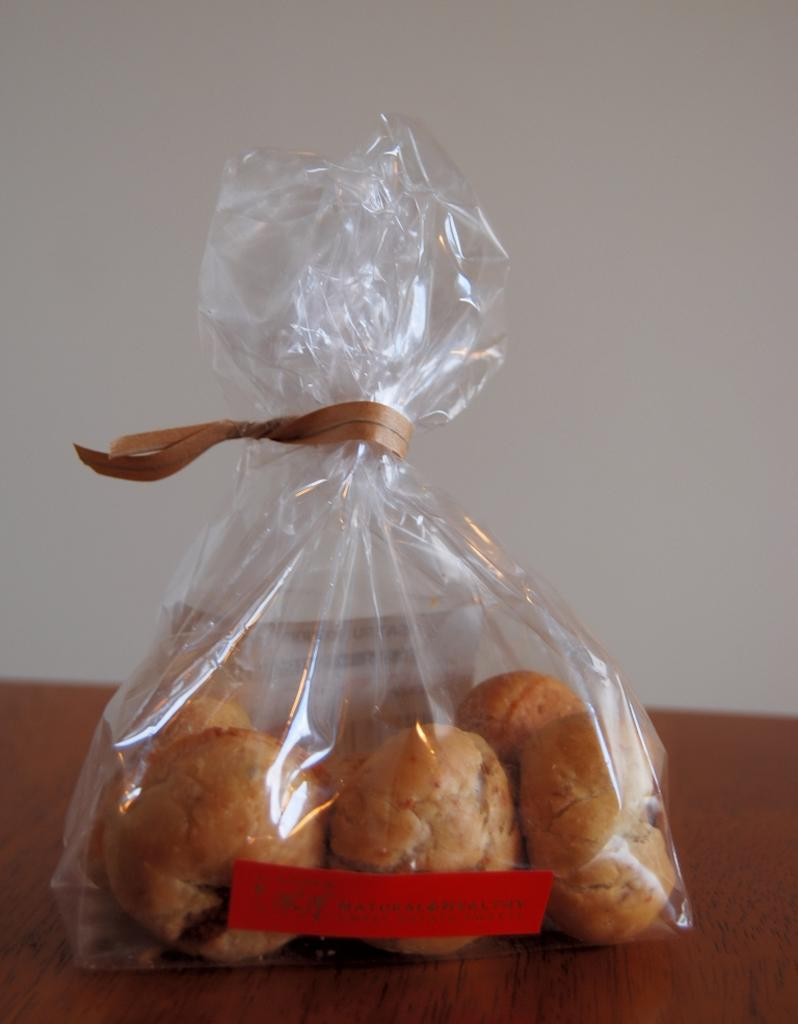What object in the image is made of plastic? There is a plastic bag in the image. What can be found on the plastic bag? The plastic bag has labels. What type of item is present in the image that can be consumed? There is food in the image. What piece of furniture is visible in the image? There is a table in the image. What type of humor can be found in the image? There is no humor present in the image; it is a simple scene featuring a plastic bag, labels, food, and a table. 